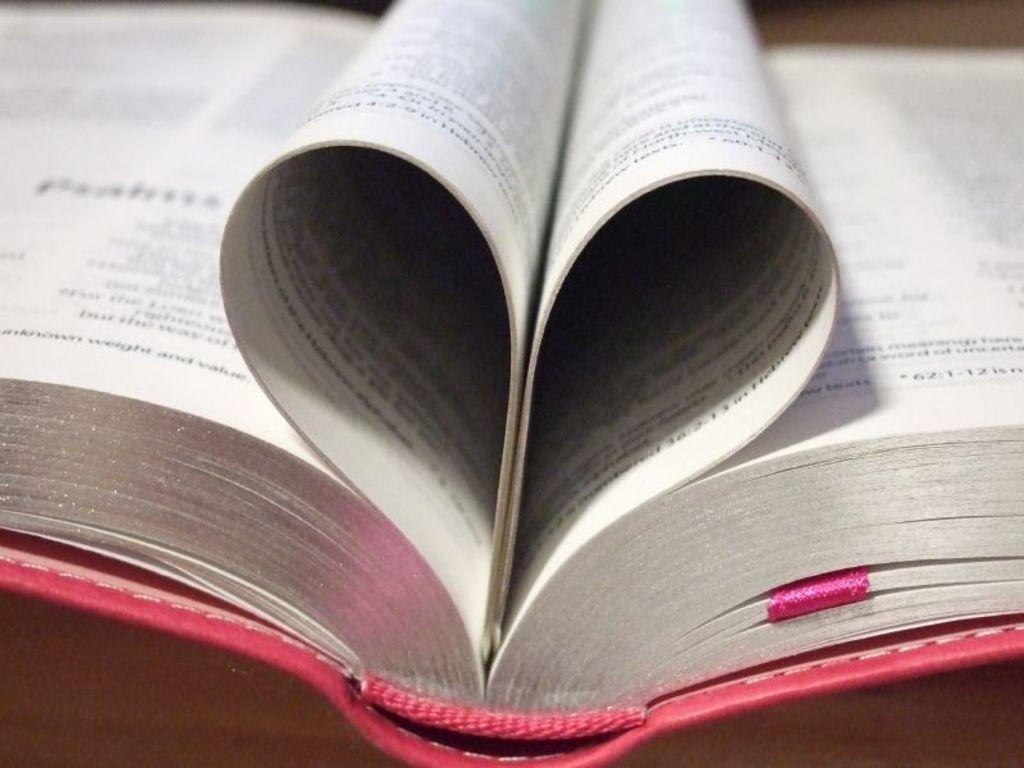<image>
Describe the image concisely. A book with a pink cover has the numbers 36:2-13 on the page that is curled up to look like a heart. 